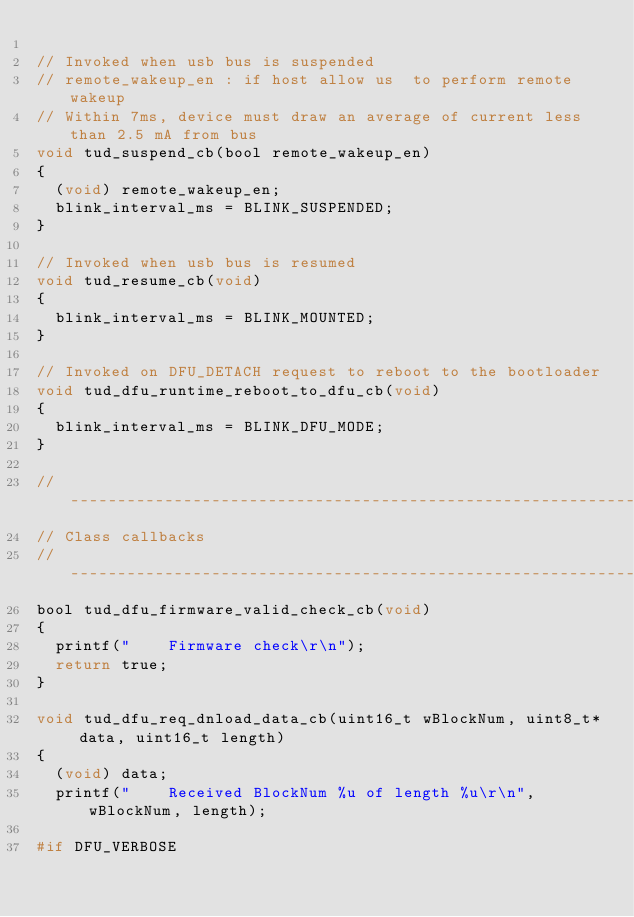Convert code to text. <code><loc_0><loc_0><loc_500><loc_500><_C_>
// Invoked when usb bus is suspended
// remote_wakeup_en : if host allow us  to perform remote wakeup
// Within 7ms, device must draw an average of current less than 2.5 mA from bus
void tud_suspend_cb(bool remote_wakeup_en)
{
  (void) remote_wakeup_en;
  blink_interval_ms = BLINK_SUSPENDED;
}

// Invoked when usb bus is resumed
void tud_resume_cb(void)
{
  blink_interval_ms = BLINK_MOUNTED;
}

// Invoked on DFU_DETACH request to reboot to the bootloader
void tud_dfu_runtime_reboot_to_dfu_cb(void)
{
  blink_interval_ms = BLINK_DFU_MODE;
}

//--------------------------------------------------------------------+
// Class callbacks
//--------------------------------------------------------------------+
bool tud_dfu_firmware_valid_check_cb(void)
{
  printf("    Firmware check\r\n");
  return true;
}

void tud_dfu_req_dnload_data_cb(uint16_t wBlockNum, uint8_t* data, uint16_t length)
{
  (void) data;
  printf("    Received BlockNum %u of length %u\r\n", wBlockNum, length);

#if DFU_VERBOSE</code> 